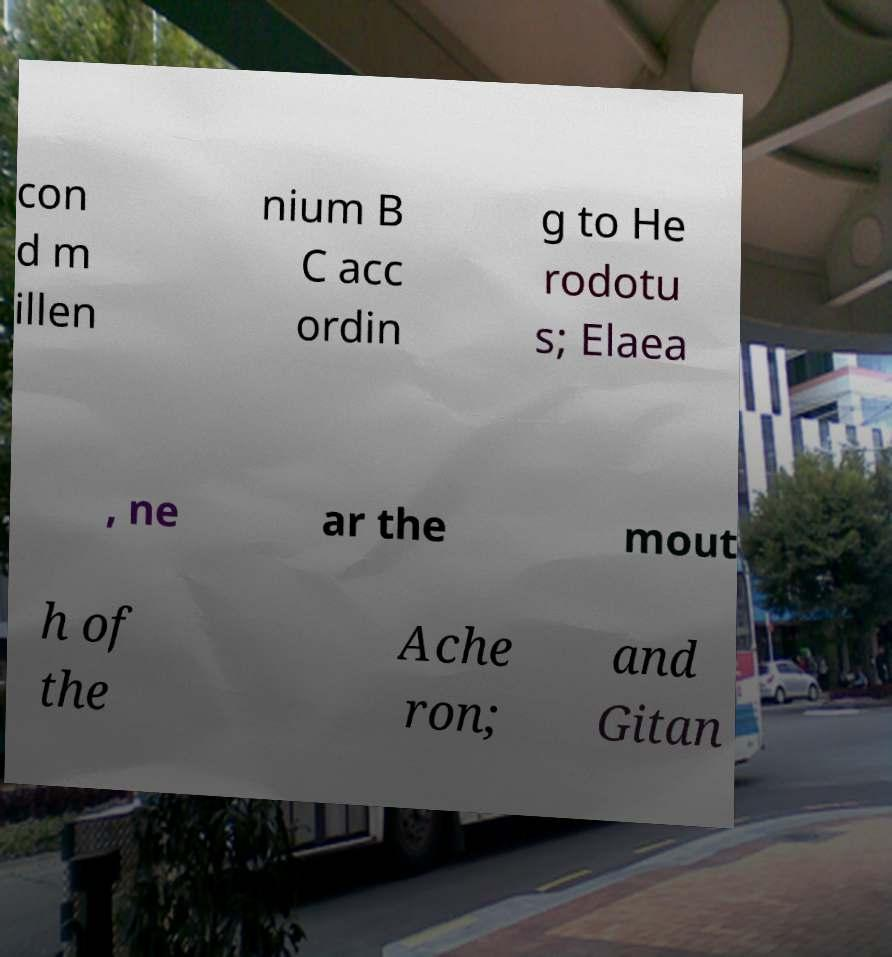Please identify and transcribe the text found in this image. con d m illen nium B C acc ordin g to He rodotu s; Elaea , ne ar the mout h of the Ache ron; and Gitan 